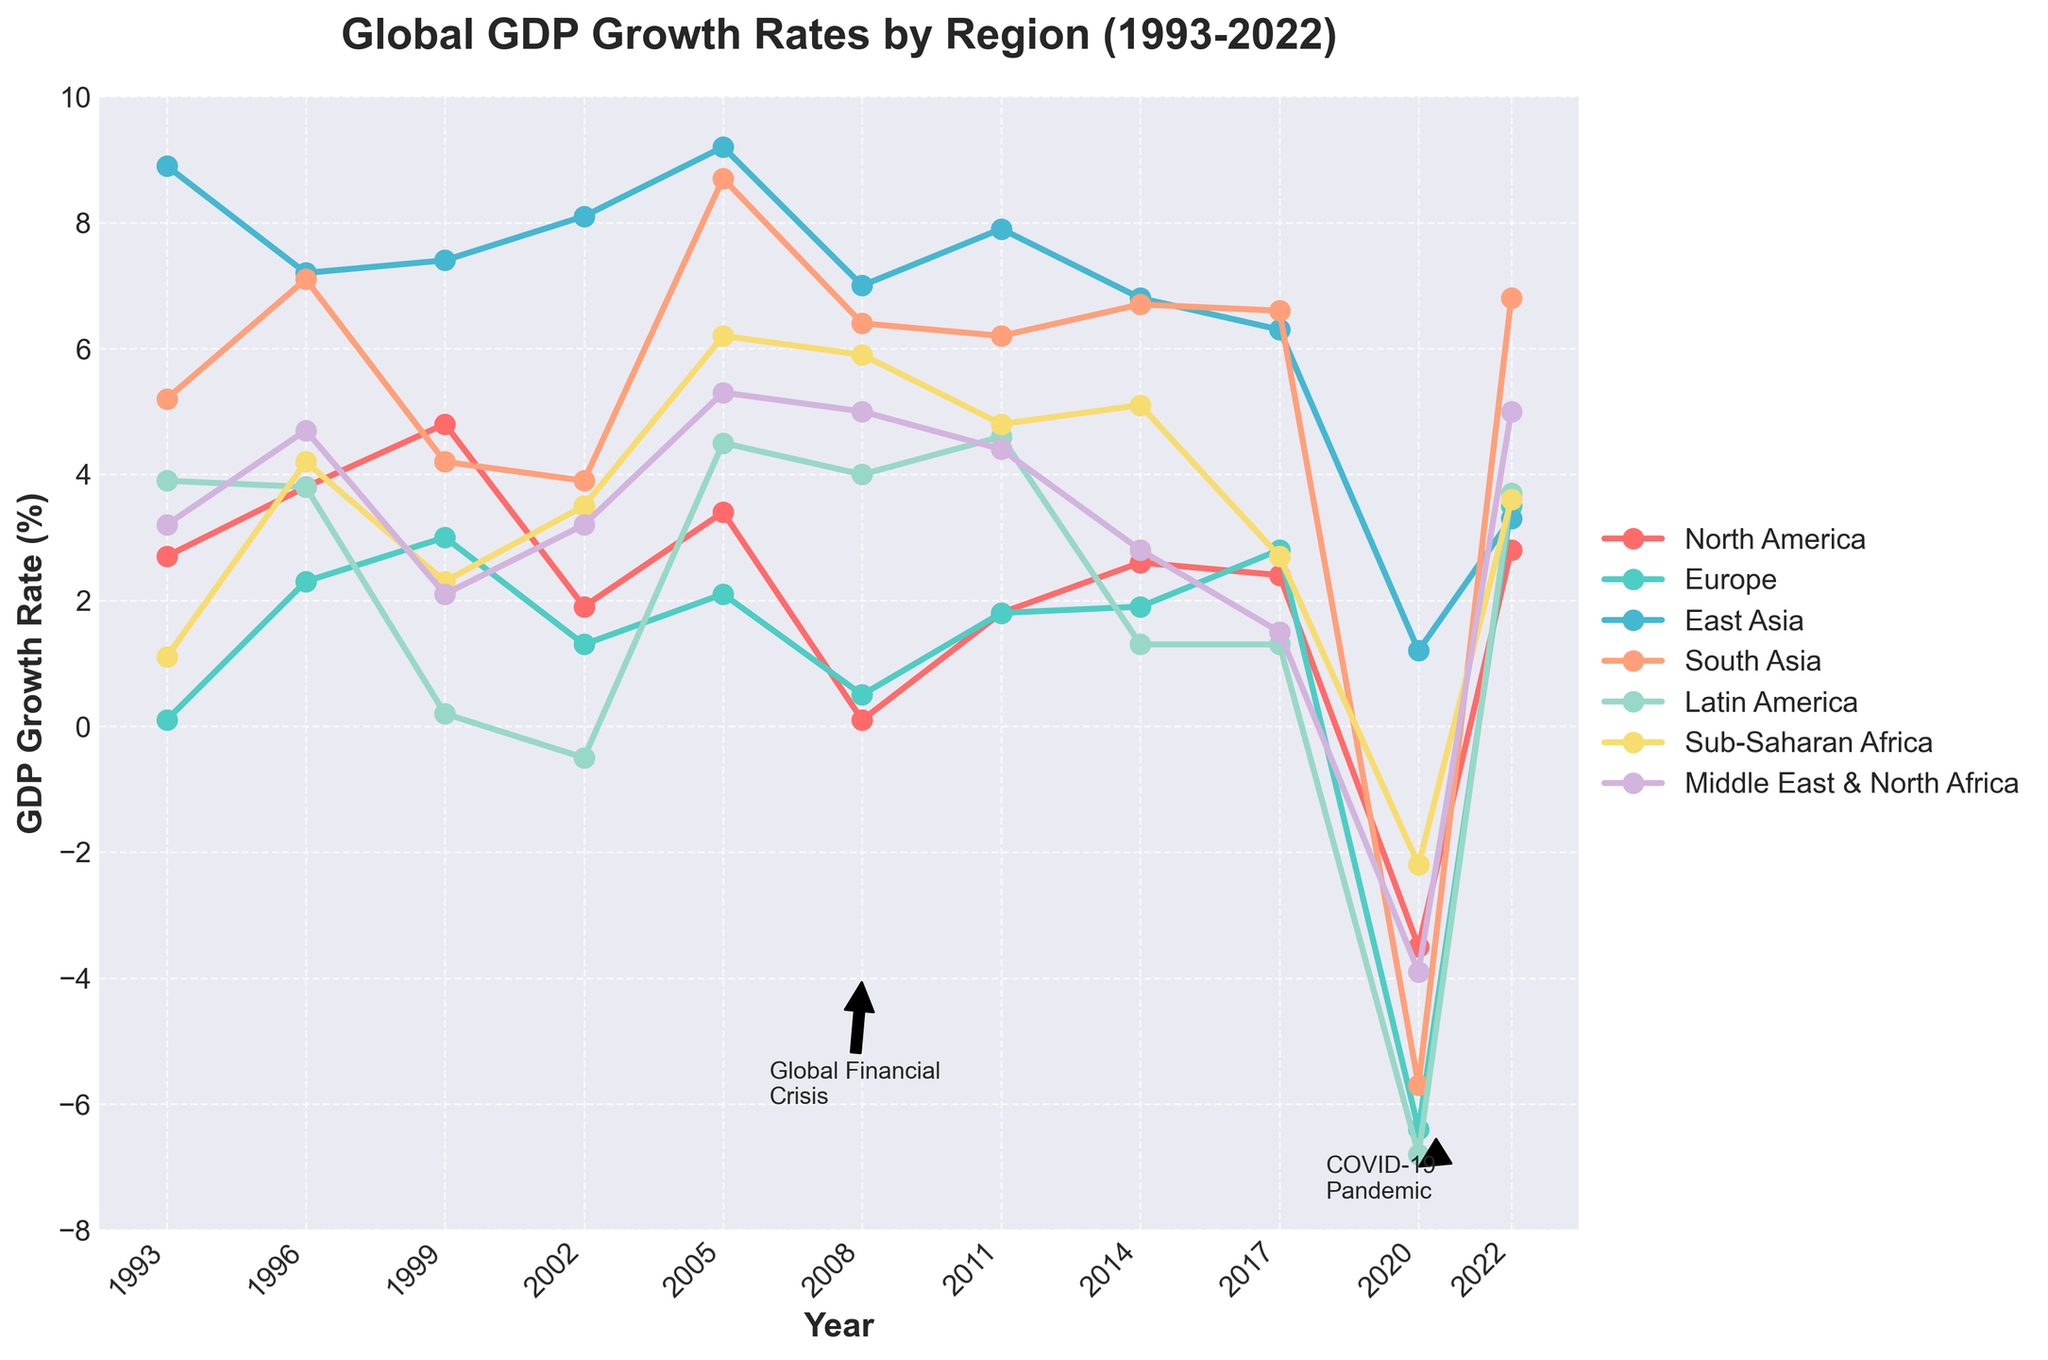What was the GDP growth rate for North America in 1999? Look for the data point corresponding to North America in 1999 on the line chart.
Answer: 4.8% Which region had the highest GDP growth rate in 2005? Compare the GDP growth rates of all regions in 2005 and identify the highest value.
Answer: East Asia How did the GDP growth rate of Latin America change from 1993 to 1999? Look at the GDP growth rates of Latin America in 1993 and 1999, then calculate the difference: 1999 rate - 1993 rate = 0.2% - 3.9%.
Answer: -3.7% Compare the GDP growth rates of Europe and East Asia in 2008. Which region had a higher rate? Analyze the values in 2008 for both Europe and East Asia. Europe was at 0.5%, and East Asia was at 7.0%.
Answer: East Asia What was the trend in Sub-Saharan Africa's GDP growth rate from 2002 to 2005? Observe the data points for Sub-Saharan Africa from 2002 to 2005, noting the values: 3.5% in 2002 and 6.2% in 2005. The GDP growth rate increased over this period.
Answer: Increased What is the average GDP growth rate of South Asia over the period shown? Sum the GDP growth rates of South Asia for all given years and divide by the number of those years: (5.2 + 7.1 + 4.2 + 3.9 + 8.7 + 6.4 + 6.2 + 6.7 + 6.6 + -5.7 + 6.8) / 11.
Answer: 5.25% Which region experienced the most significant drop in GDP growth rate from 2017 to 2020? Calculate the differences in GDP growth rates from 2017 to 2020 for each region, then compare the magnitude of these differences. The largest decrease is in Europe, from 2.8% to -6.4%.
Answer: Europe What visual attributes help identify the COVID-19 pandemic's effect on GDP growth rates? Refer to the arrow annotation labeled "COVID-19 Pandemic" pointing to the significant drops in GDP growth rates around 2020.
Answer: Arrow annotation Did North America's GDP growth rate ever decline to negative in the provided period? If so, when? Check the line representing North America for any points below zero. The rate was -3.5% in 2020.
Answer: 2020 How does the GDP growth rate of the Middle East & North Africa in 2022 compare to that in 2008? Look at the data points for the Middle East & North Africa in 2022 and 2008, then note whether the 2022 rate (5.0%) is higher or lower than the 2008 rate (5.0%).
Answer: Equal 